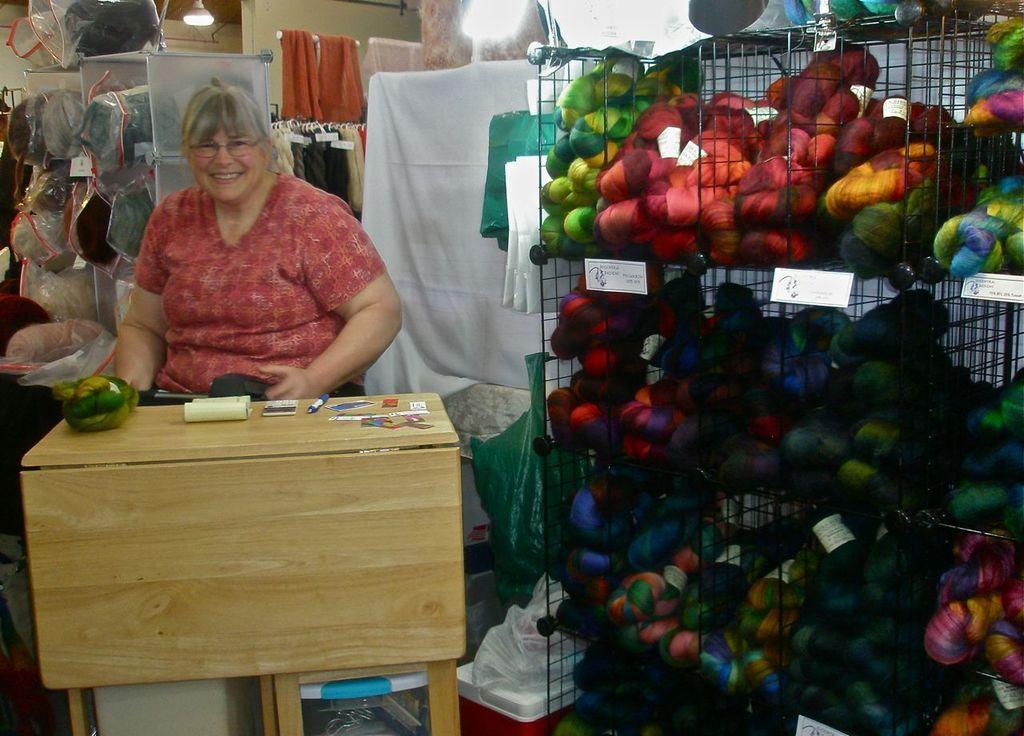Describe this image in one or two sentences. This is an image clicked inside the room. On the right side there is a rack filled with some objects. On the left side there is a woman wearing red color dress, sitting on the chair in front of the table. In the background there are few clothes hanging to a stick. 